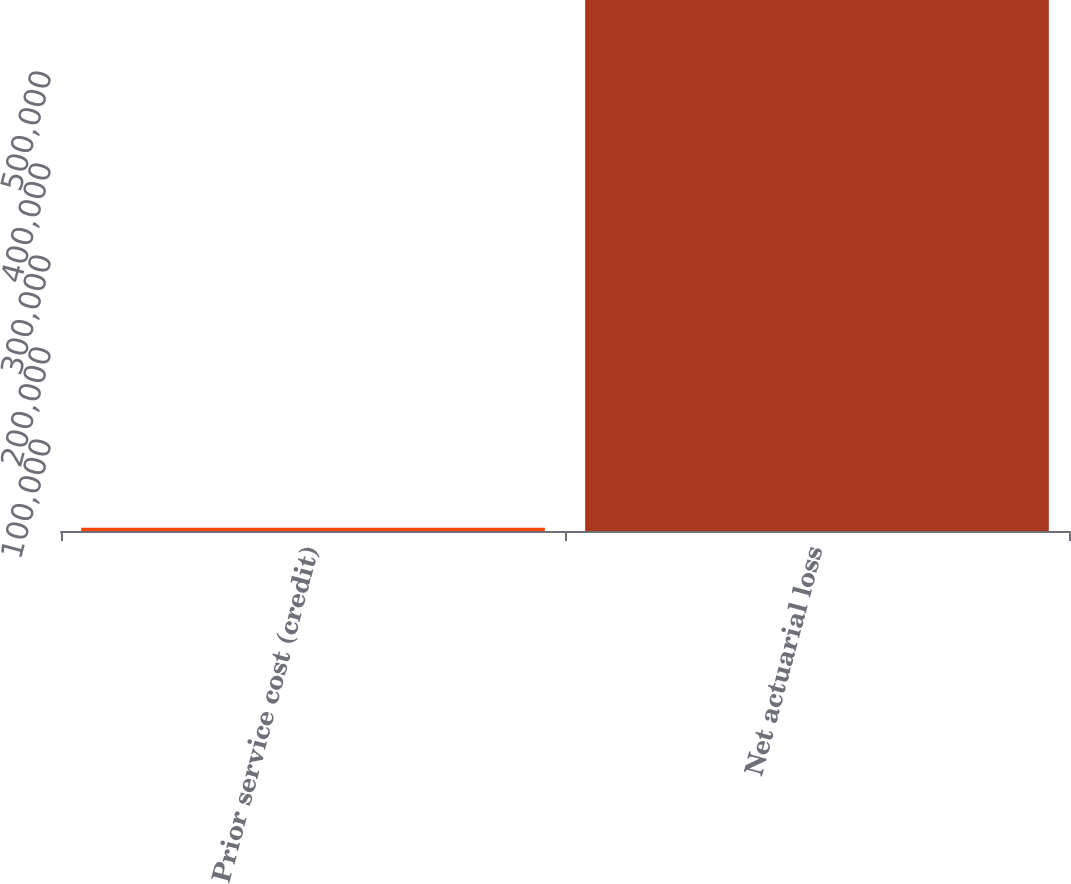Convert chart. <chart><loc_0><loc_0><loc_500><loc_500><bar_chart><fcel>Prior service cost (credit)<fcel>Net actuarial loss<nl><fcel>3489<fcel>577140<nl></chart> 